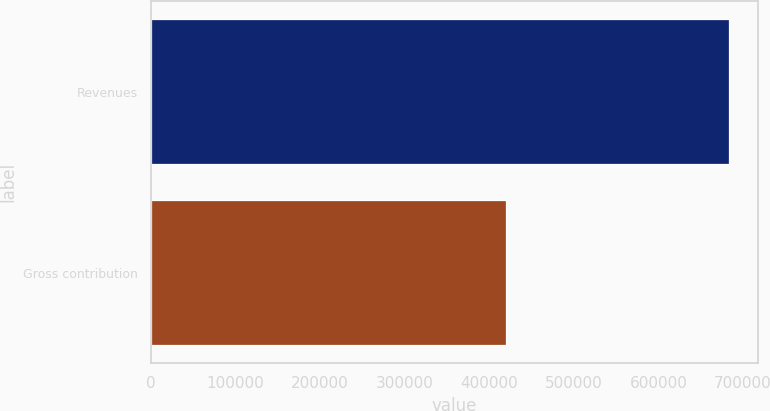<chart> <loc_0><loc_0><loc_500><loc_500><bar_chart><fcel>Revenues<fcel>Gross contribution<nl><fcel>683380<fcel>419639<nl></chart> 